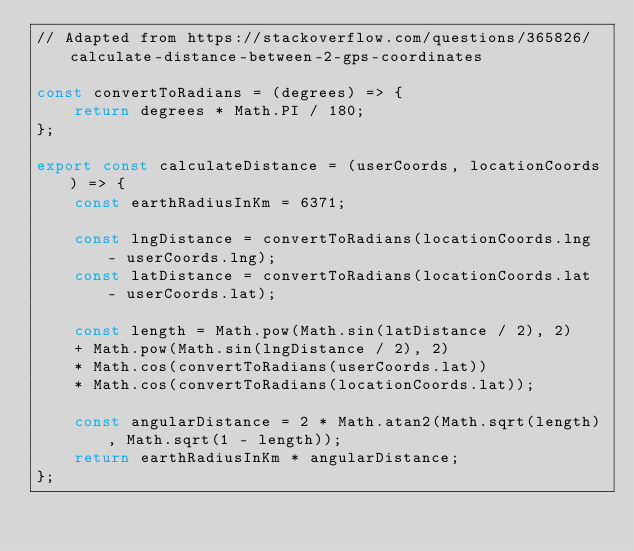<code> <loc_0><loc_0><loc_500><loc_500><_JavaScript_>// Adapted from https://stackoverflow.com/questions/365826/calculate-distance-between-2-gps-coordinates

const convertToRadians = (degrees) => {
    return degrees * Math.PI / 180;
};

export const calculateDistance = (userCoords, locationCoords) => {    
    const earthRadiusInKm = 6371;

    const lngDistance = convertToRadians(locationCoords.lng - userCoords.lng);
    const latDistance = convertToRadians(locationCoords.lat - userCoords.lat);

    const length = Math.pow(Math.sin(latDistance / 2), 2)
    + Math.pow(Math.sin(lngDistance / 2), 2)
    * Math.cos(convertToRadians(userCoords.lat))
    * Math.cos(convertToRadians(locationCoords.lat));
    
    const angularDistance = 2 * Math.atan2(Math.sqrt(length), Math.sqrt(1 - length)); 
    return earthRadiusInKm * angularDistance;
};</code> 